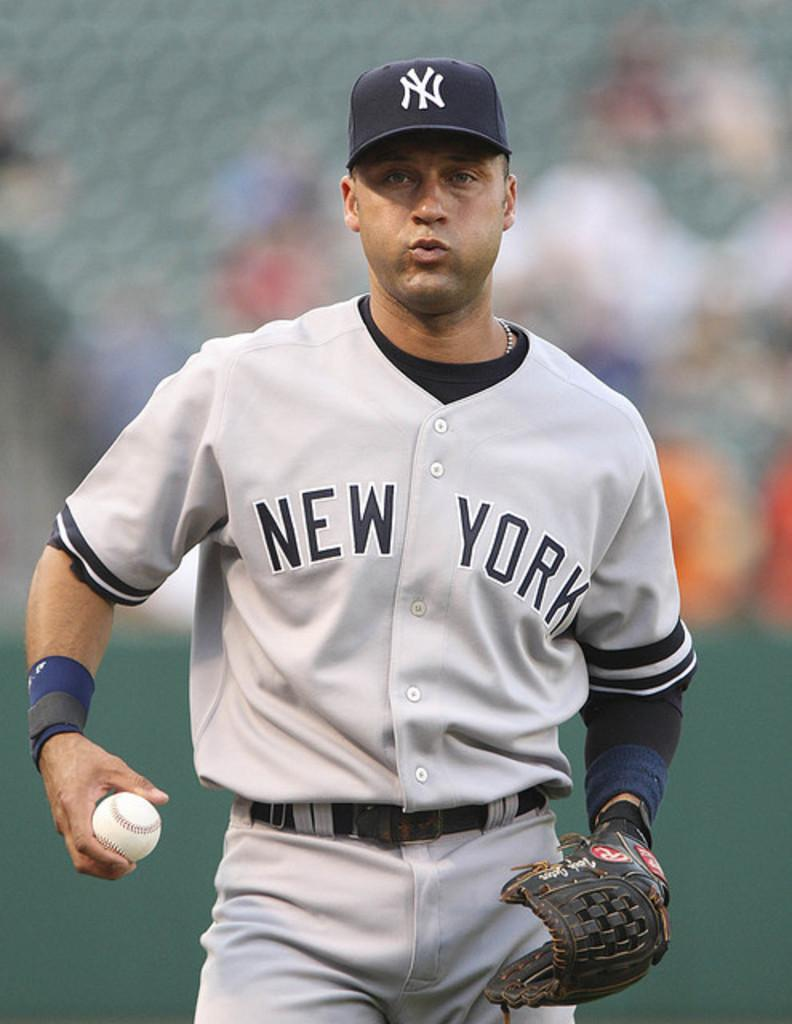<image>
Share a concise interpretation of the image provided. A ball player wearing a New York jersey. 